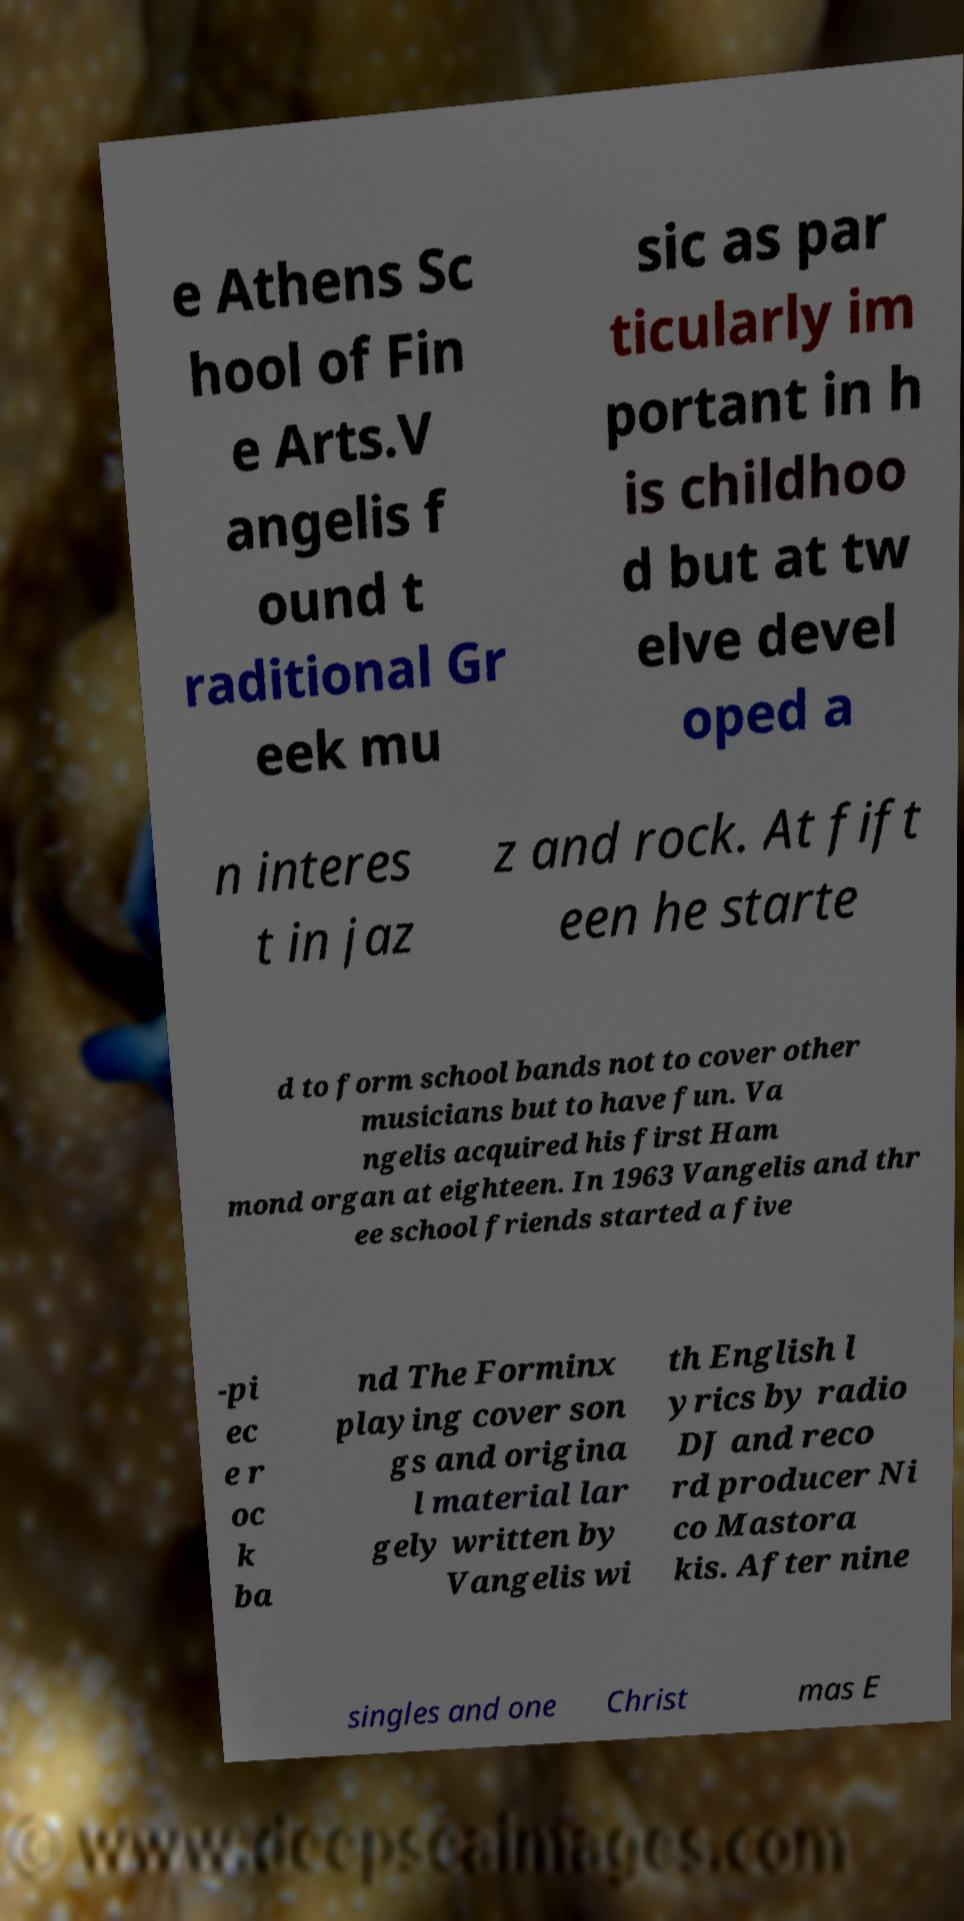Could you assist in decoding the text presented in this image and type it out clearly? e Athens Sc hool of Fin e Arts.V angelis f ound t raditional Gr eek mu sic as par ticularly im portant in h is childhoo d but at tw elve devel oped a n interes t in jaz z and rock. At fift een he starte d to form school bands not to cover other musicians but to have fun. Va ngelis acquired his first Ham mond organ at eighteen. In 1963 Vangelis and thr ee school friends started a five -pi ec e r oc k ba nd The Forminx playing cover son gs and origina l material lar gely written by Vangelis wi th English l yrics by radio DJ and reco rd producer Ni co Mastora kis. After nine singles and one Christ mas E 